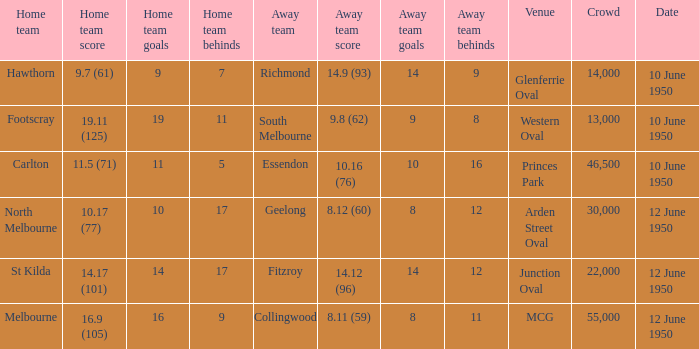Could you help me parse every detail presented in this table? {'header': ['Home team', 'Home team score', 'Home team goals', 'Home team behinds', 'Away team', 'Away team score', 'Away team goals', 'Away team behinds', 'Venue', 'Crowd', 'Date'], 'rows': [['Hawthorn', '9.7 (61)', '9', '7', 'Richmond', '14.9 (93)', '14', '9', 'Glenferrie Oval', '14,000', '10 June 1950'], ['Footscray', '19.11 (125)', '19', '11', 'South Melbourne', '9.8 (62)', '9', '8', 'Western Oval', '13,000', '10 June 1950'], ['Carlton', '11.5 (71)', '11', '5', 'Essendon', '10.16 (76)', '10', '16', 'Princes Park', '46,500', '10 June 1950'], ['North Melbourne', '10.17 (77)', '10', '17', 'Geelong', '8.12 (60)', '8', '12', 'Arden Street Oval', '30,000', '12 June 1950'], ['St Kilda', '14.17 (101)', '14', '17', 'Fitzroy', '14.12 (96)', '14', '12', 'Junction Oval', '22,000', '12 June 1950'], ['Melbourne', '16.9 (105)', '16', '9', 'Collingwood', '8.11 (59)', '8', '11', 'MCG', '55,000', '12 June 1950']]} What was the crowd when Melbourne was the home team? 55000.0. 